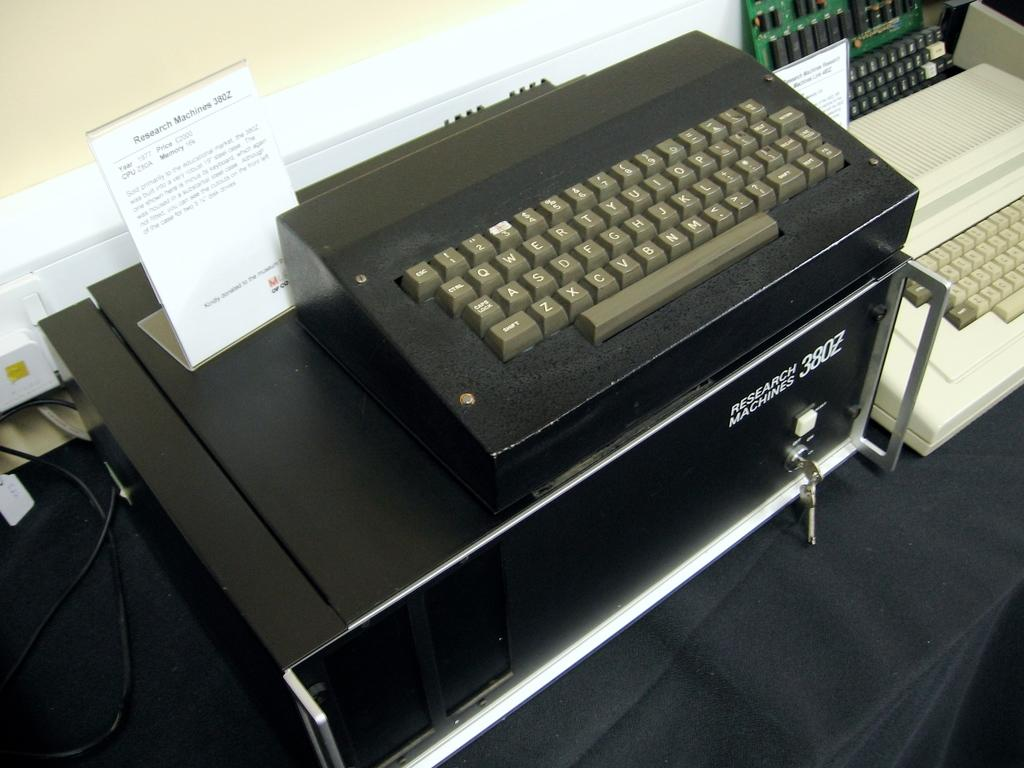<image>
Provide a brief description of the given image. Research Machines 380Z equipment with key inserted in the front. 